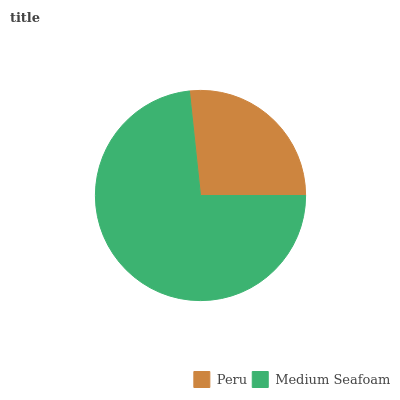Is Peru the minimum?
Answer yes or no. Yes. Is Medium Seafoam the maximum?
Answer yes or no. Yes. Is Medium Seafoam the minimum?
Answer yes or no. No. Is Medium Seafoam greater than Peru?
Answer yes or no. Yes. Is Peru less than Medium Seafoam?
Answer yes or no. Yes. Is Peru greater than Medium Seafoam?
Answer yes or no. No. Is Medium Seafoam less than Peru?
Answer yes or no. No. Is Medium Seafoam the high median?
Answer yes or no. Yes. Is Peru the low median?
Answer yes or no. Yes. Is Peru the high median?
Answer yes or no. No. Is Medium Seafoam the low median?
Answer yes or no. No. 